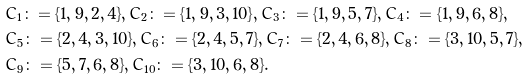<formula> <loc_0><loc_0><loc_500><loc_500>& C _ { 1 } \colon = \{ 1 , 9 , 2 , 4 \} , C _ { 2 } \colon = \{ 1 , 9 , 3 , 1 0 \} , C _ { 3 } \colon = \{ 1 , 9 , 5 , 7 \} , C _ { 4 } \colon = \{ 1 , 9 , 6 , 8 \} , \\ & C _ { 5 } \colon = \{ 2 , 4 , 3 , 1 0 \} , C _ { 6 } \colon = \{ 2 , 4 , 5 , 7 \} , C _ { 7 } \colon = \{ 2 , 4 , 6 , 8 \} , C _ { 8 } \colon = \{ 3 , 1 0 , 5 , 7 \} , \\ & C _ { 9 } \colon = \{ 5 , 7 , 6 , 8 \} , C _ { 1 0 } \colon = \{ 3 , 1 0 , 6 , 8 \} .</formula> 